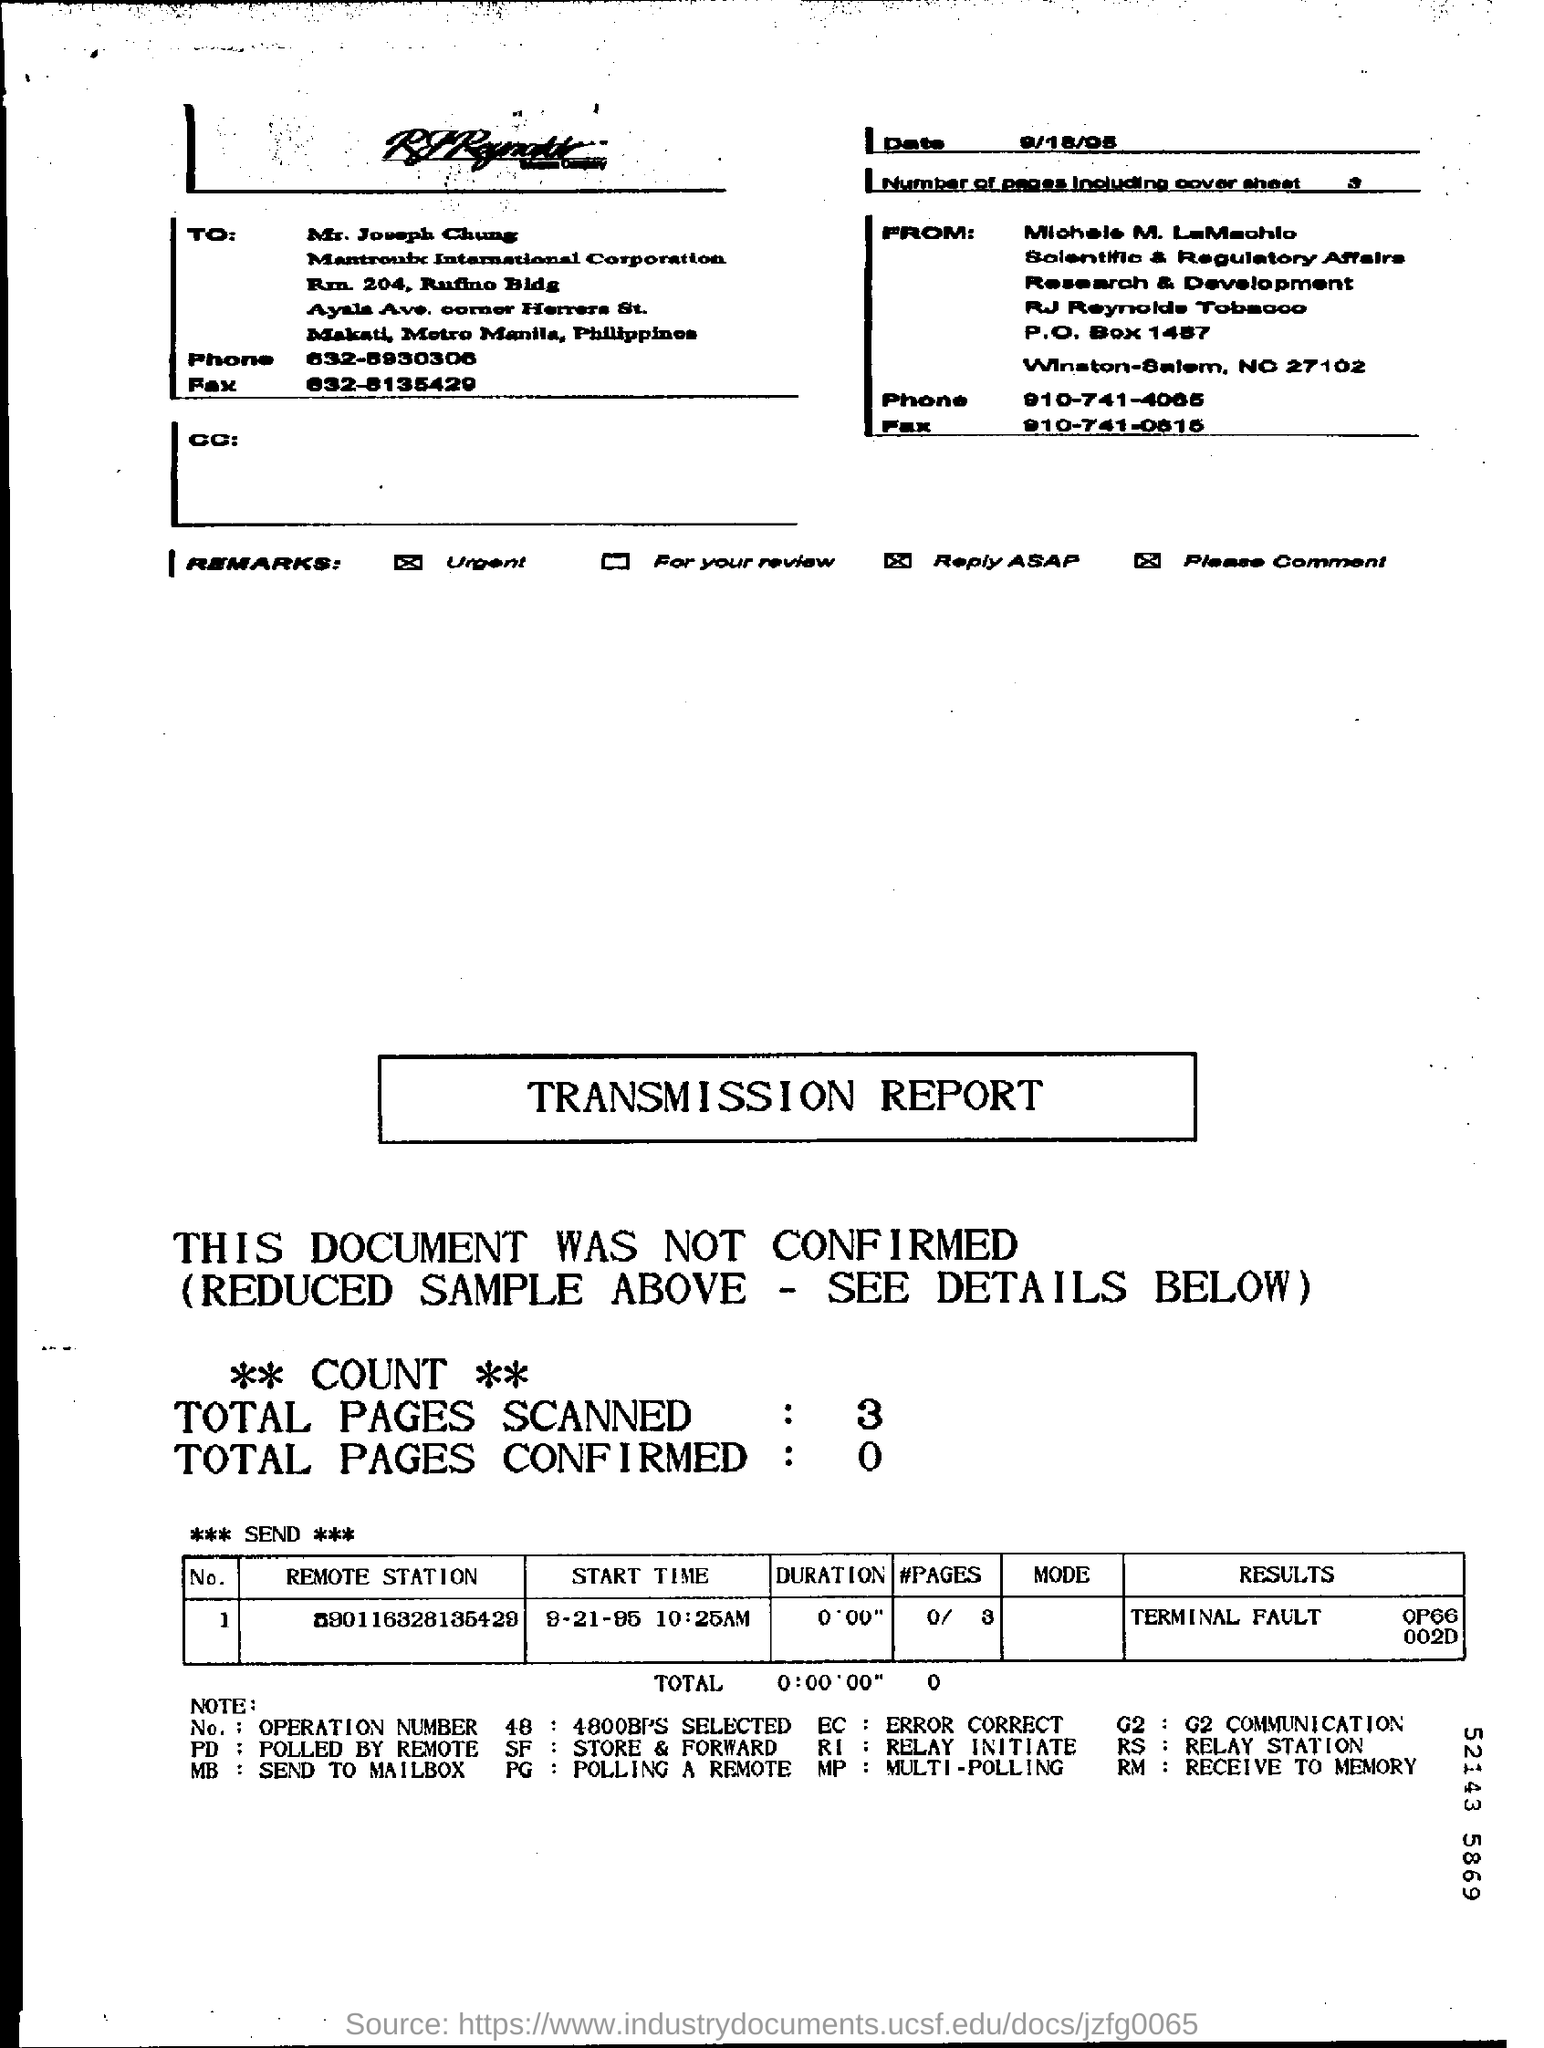What is the Date?
Make the answer very short. 9/18/05. Which is the only remark which is not ticked ?
Make the answer very short. For your review. To Whom is this Fax addressed to?
Make the answer very short. Mr. Joseph Chung. What is the "Start Time"?
Your answer should be very brief. 9-21-95 10:25AM. What is the "Duration"?
Give a very brief answer. 0'0'0". What is the fault mentioned in "results"?
Your answer should be compact. Terminal fault. What are the Total Pages Scanned?
Provide a succinct answer. 3. What are the Total Pages Confirmed?
Make the answer very short. 0. What are the Number of Pages including Cover sheet?
Offer a very short reply. 3. What is the "#Pages" in the table in the bottom?
Give a very brief answer. 0/ 3. 